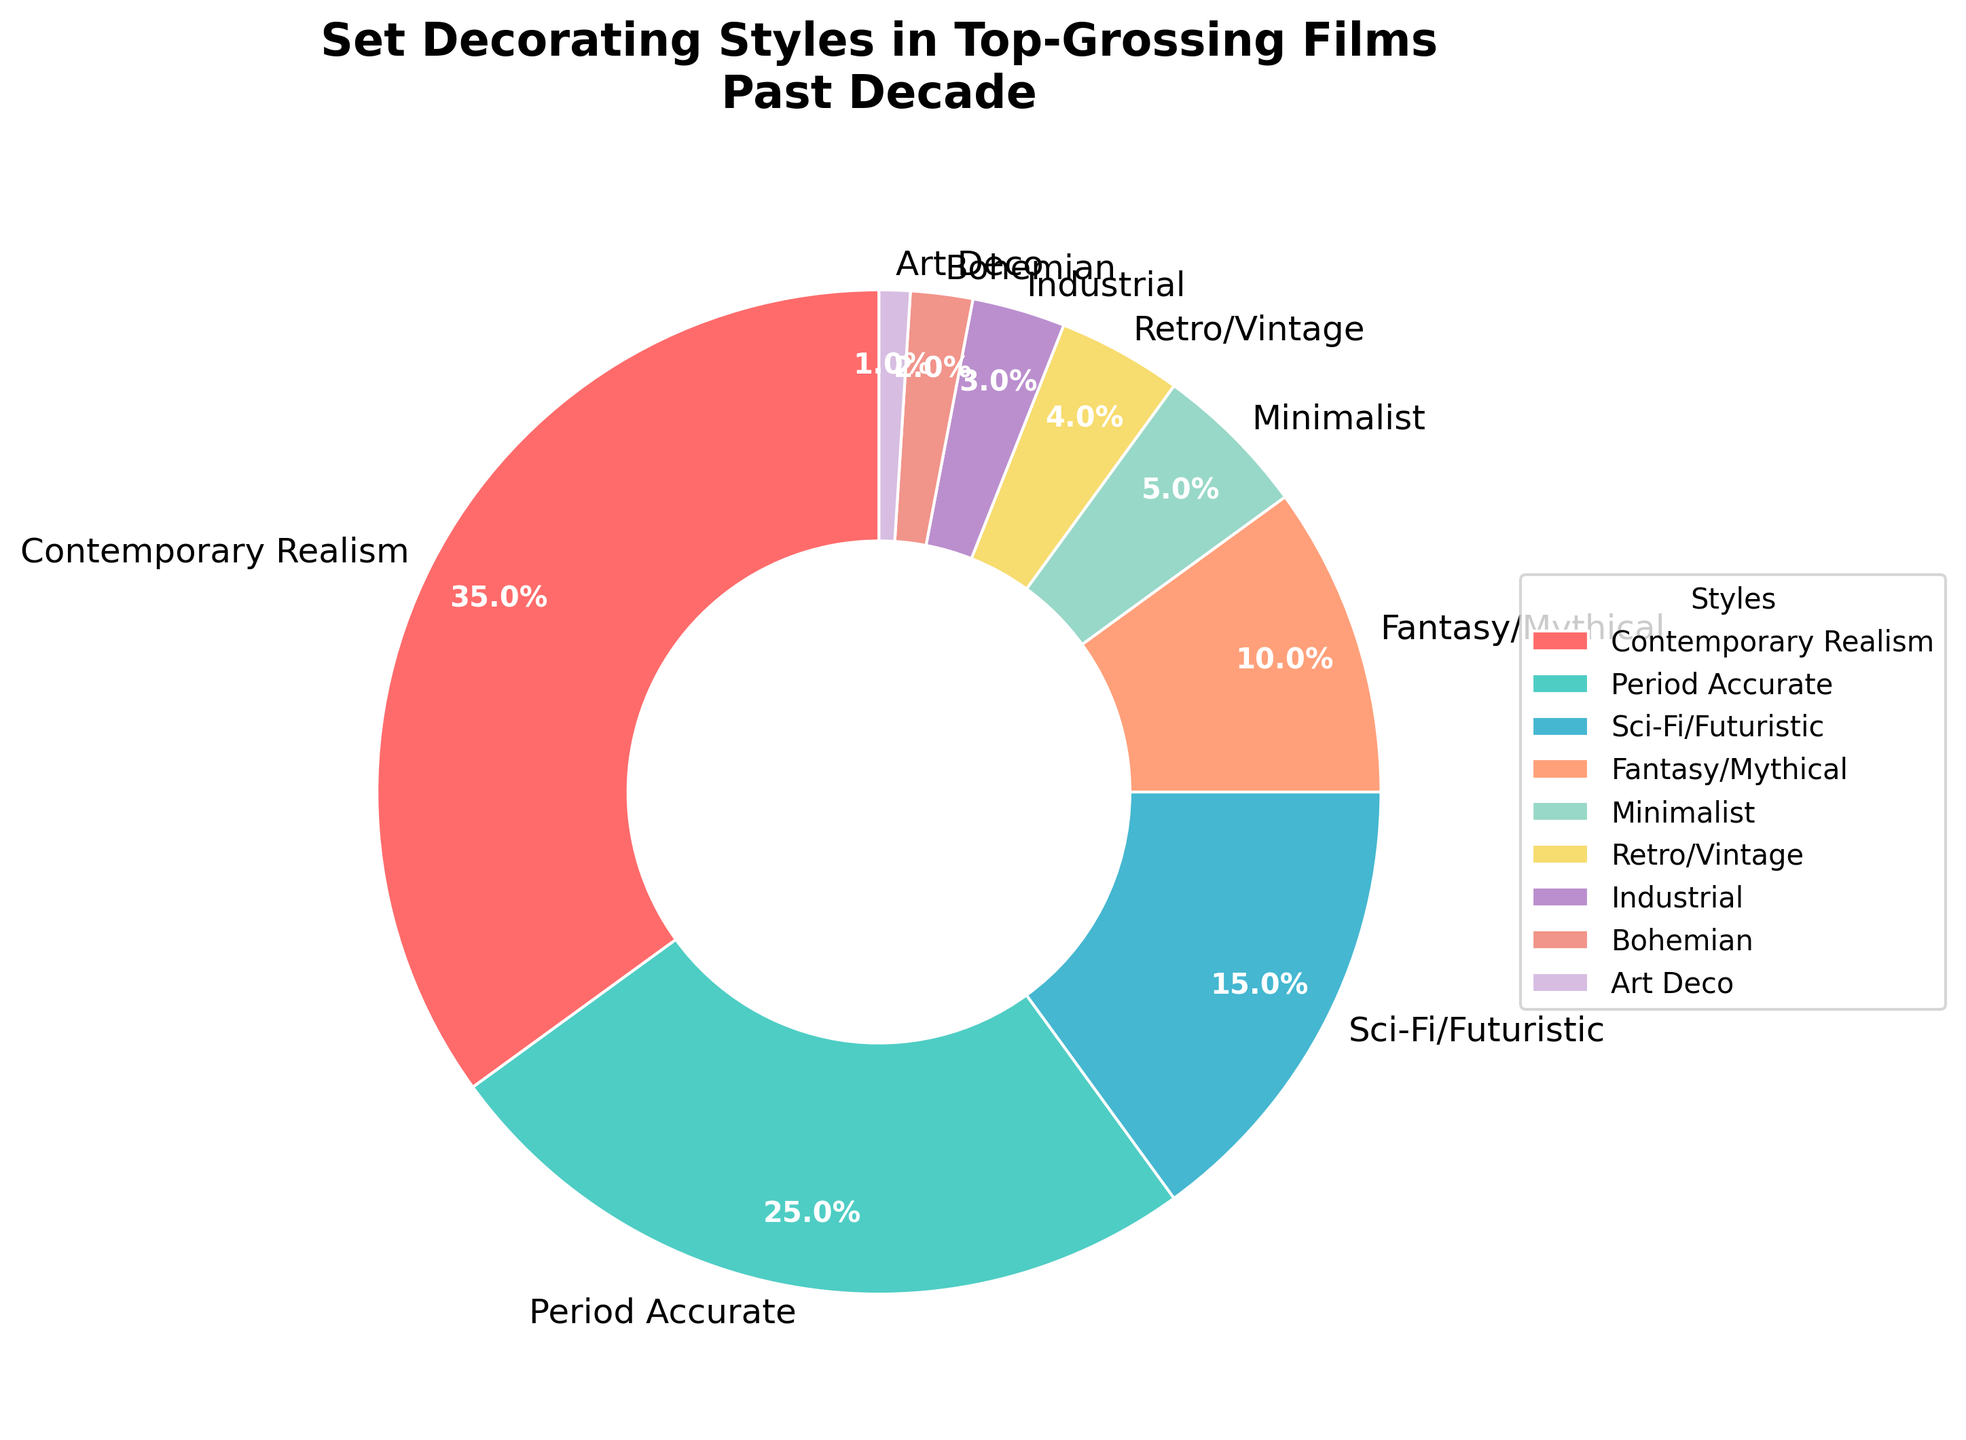Which set decorating style is used the most in top-grossing films of the past decade? The pie chart shows the percentage for each style, and the largest slice belongs to "Contemporary Realism" with 35%.
Answer: Contemporary Realism Which set decorating style is the least used in top-grossing films of the past decade? The smallest slice of the pie chart represents "Art Deco," with only 1%.
Answer: Art Deco What is the combined percentage of "Sci-Fi/Futuristic" and "Fantasy/Mythical" styles? The percentage for "Sci-Fi/Futuristic" is 15%, and for "Fantasy/Mythical" is 10%. Adding these together gives: 15% + 10% = 25%.
Answer: 25% How much more popular is "Contemporary Realism" than "Period Accurate"? "Contemporary Realism" has 35%, and "Period Accurate" has 25%. The difference is 35% - 25% = 10%.
Answer: 10% Which style occupies the yellowish color in the pie chart? The yellowish slice in the pie chart is "Sci-Fi/Futuristic," which accounts for 15%.
Answer: Sci-Fi/Futuristic What style comes third in terms of usage percentage? The pie chart shows "Sci-Fi/Futuristic" with 15%, which is the third largest percentage after "Contemporary Realism" and "Period Accurate."
Answer: Sci-Fi/Futuristic Is the combined percentage of "Industrial," "Bohemian," "Art Deco," and "Retro/Vintage" greater than the "Period Accurate" style? The sum of "Industrial" (3%), "Bohemian" (2%), "Art Deco" (1%), and "Retro/Vintage" (4%) is 3% + 2% + 1% + 4% = 10%. "Period Accurate" alone is 25%, so the combined percentage is not greater.
Answer: No Which styles are represented by slices with black outlines in the pie chart? The pie chart has a black outline for all the wedges, so all styles listed (e.g., "Contemporary Realism," "Period Accurate," etc.) have black outlines.
Answer: All styles Calculate the average percentage usage of the three least used styles shown. The three least used styles are "Art Deco" (1%), "Bohemian" (2%), and "Industrial" (3%). The average is calculated as (1% + 2% + 3%) / 3 = 6% / 3 = 2%.
Answer: 2% If we group "Minimalist," "Retro/Vintage," "Industrial," "Bohemian," and "Art Deco" styles, what percentage of top-grossing films use these? The percentages are 5% ("Minimalist"), 4% ("Retro/Vintage"), 3% ("Industrial"), 2% ("Bohemian"), and 1% ("Art Deco"). Summing these gives: 5% + 4% + 3% + 2% + 1% = 15%.
Answer: 15% 